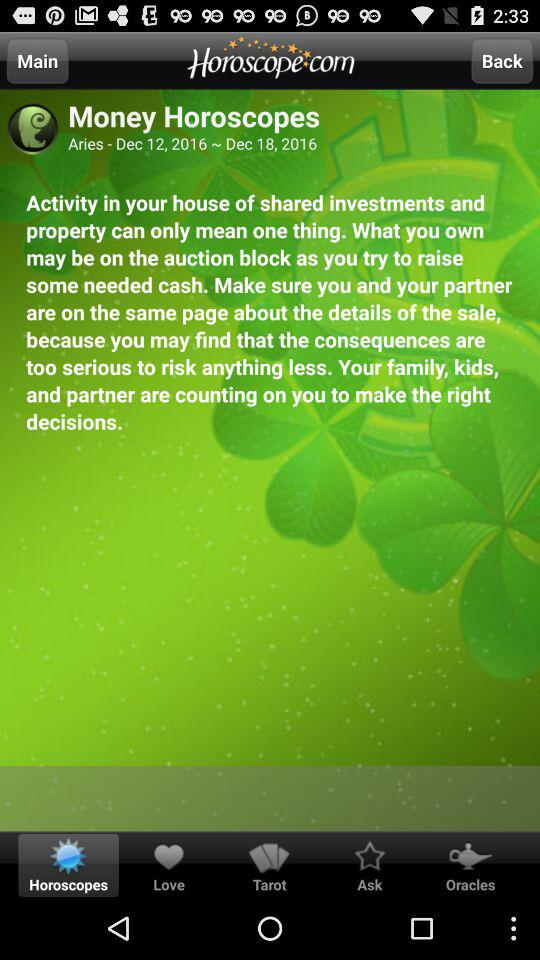What is the developer name? The developer name is "Horoscope.com". 